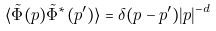Convert formula to latex. <formula><loc_0><loc_0><loc_500><loc_500>\langle \tilde { \Phi } ( p ) \tilde { \Phi } ^ { * } ( p ^ { \prime } ) \rangle = \delta ( p - p ^ { \prime } ) | p | ^ { - d }</formula> 